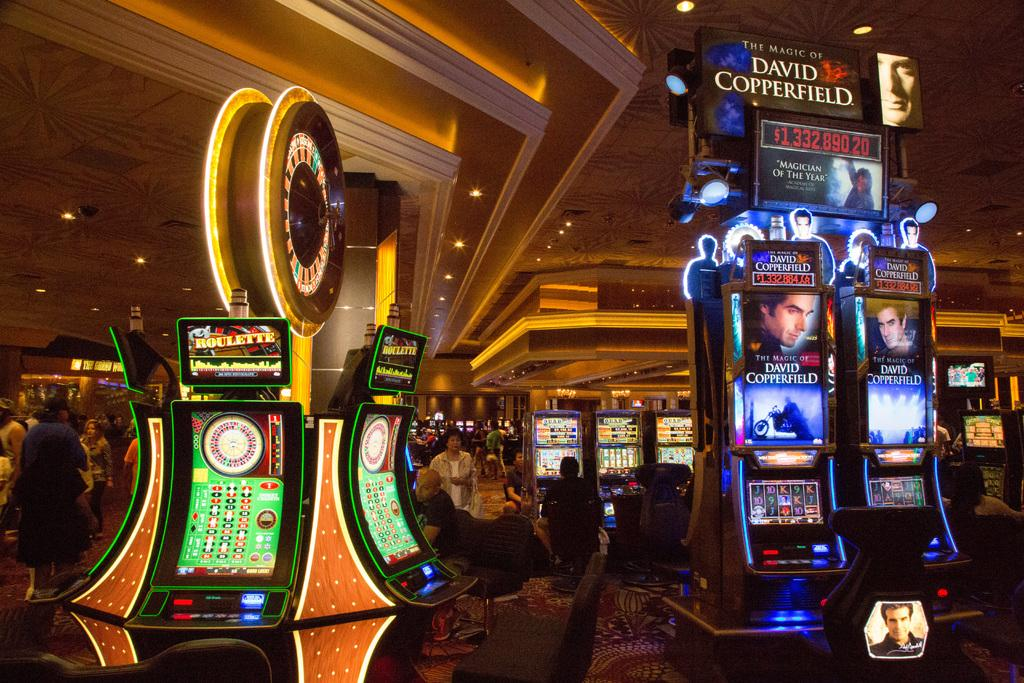What type of machines are present in the image? There are slot machines in the image. Can you describe the people in the image? There is a group of people standing in the image. What type of seating is available in the image? There are chairs in the image. What type of lighting is present in the image? There are lights in the image. What type of flooring is present in the image? There is a carpet in the image. What type of pancake is being served to the people in the image? There is no pancake present in the image. What is the condition of the hearts of the people in the image? There is no information about the hearts of the people in the image. 